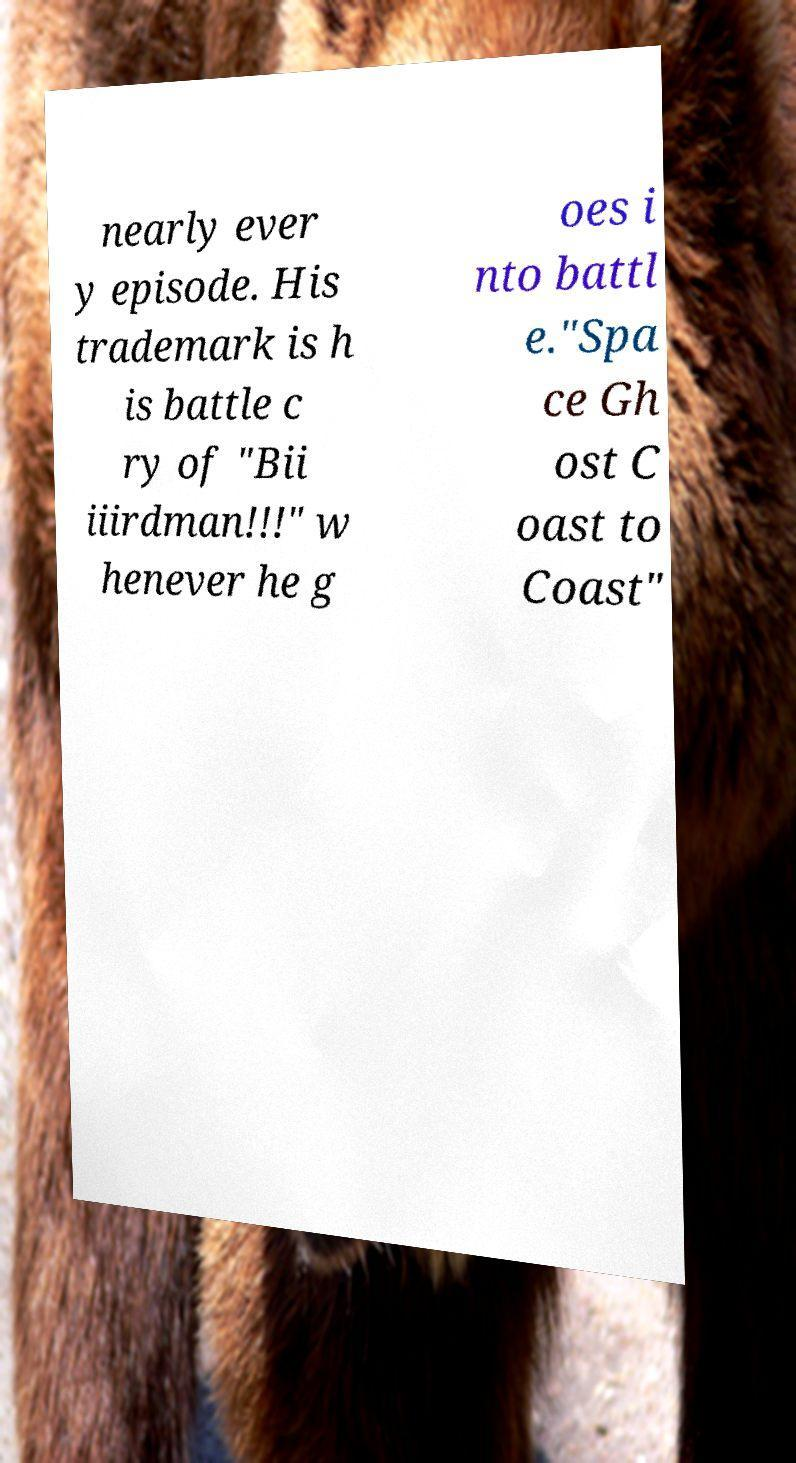I need the written content from this picture converted into text. Can you do that? nearly ever y episode. His trademark is h is battle c ry of "Bii iiirdman!!!" w henever he g oes i nto battl e."Spa ce Gh ost C oast to Coast" 